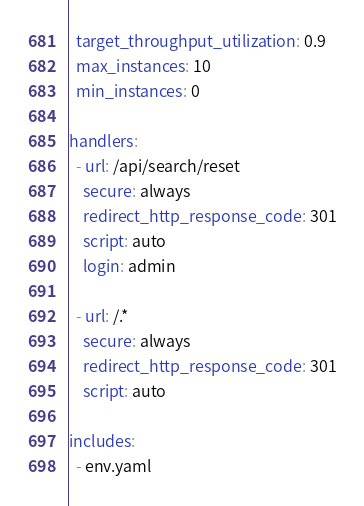Convert code to text. <code><loc_0><loc_0><loc_500><loc_500><_YAML_>  target_throughput_utilization: 0.9
  max_instances: 10
  min_instances: 0

handlers:
  - url: /api/search/reset
    secure: always
    redirect_http_response_code: 301
    script: auto
    login: admin

  - url: /.*
    secure: always
    redirect_http_response_code: 301
    script: auto

includes:
  - env.yaml
</code> 